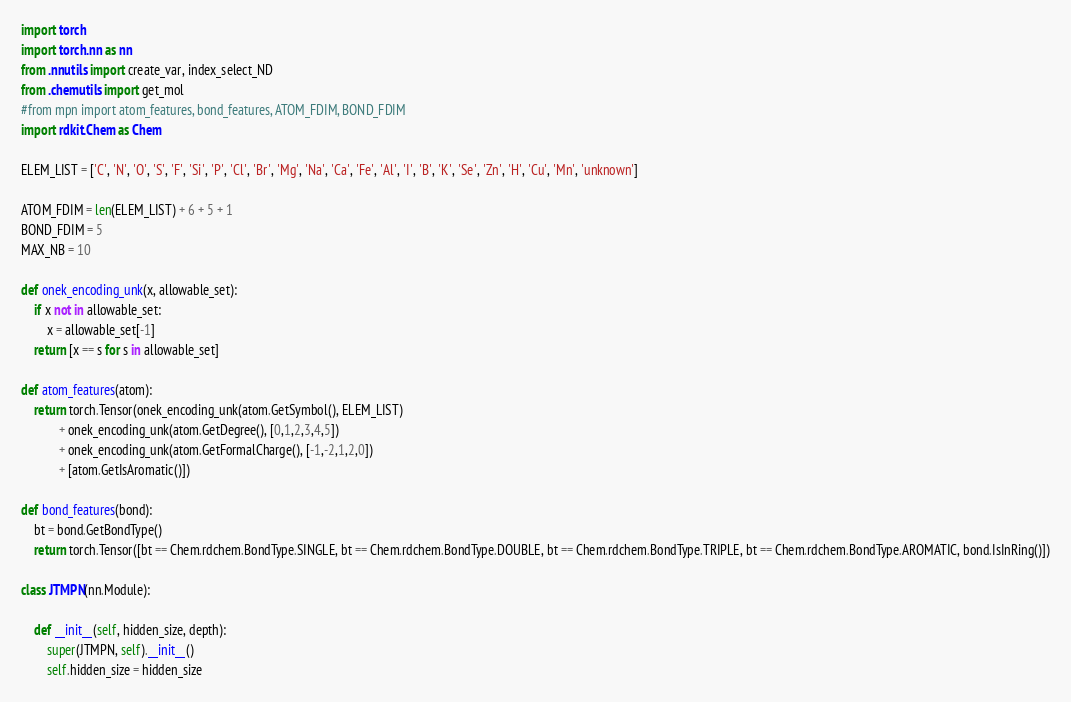Convert code to text. <code><loc_0><loc_0><loc_500><loc_500><_Python_>import torch
import torch.nn as nn
from .nnutils import create_var, index_select_ND
from .chemutils import get_mol
#from mpn import atom_features, bond_features, ATOM_FDIM, BOND_FDIM
import rdkit.Chem as Chem

ELEM_LIST = ['C', 'N', 'O', 'S', 'F', 'Si', 'P', 'Cl', 'Br', 'Mg', 'Na', 'Ca', 'Fe', 'Al', 'I', 'B', 'K', 'Se', 'Zn', 'H', 'Cu', 'Mn', 'unknown']

ATOM_FDIM = len(ELEM_LIST) + 6 + 5 + 1
BOND_FDIM = 5 
MAX_NB = 10

def onek_encoding_unk(x, allowable_set):
    if x not in allowable_set:
        x = allowable_set[-1]
    return [x == s for s in allowable_set]

def atom_features(atom):
    return torch.Tensor(onek_encoding_unk(atom.GetSymbol(), ELEM_LIST) 
            + onek_encoding_unk(atom.GetDegree(), [0,1,2,3,4,5]) 
            + onek_encoding_unk(atom.GetFormalCharge(), [-1,-2,1,2,0])
            + [atom.GetIsAromatic()])

def bond_features(bond):
    bt = bond.GetBondType()
    return torch.Tensor([bt == Chem.rdchem.BondType.SINGLE, bt == Chem.rdchem.BondType.DOUBLE, bt == Chem.rdchem.BondType.TRIPLE, bt == Chem.rdchem.BondType.AROMATIC, bond.IsInRing()])

class JTMPN(nn.Module):

    def __init__(self, hidden_size, depth):
        super(JTMPN, self).__init__()
        self.hidden_size = hidden_size</code> 